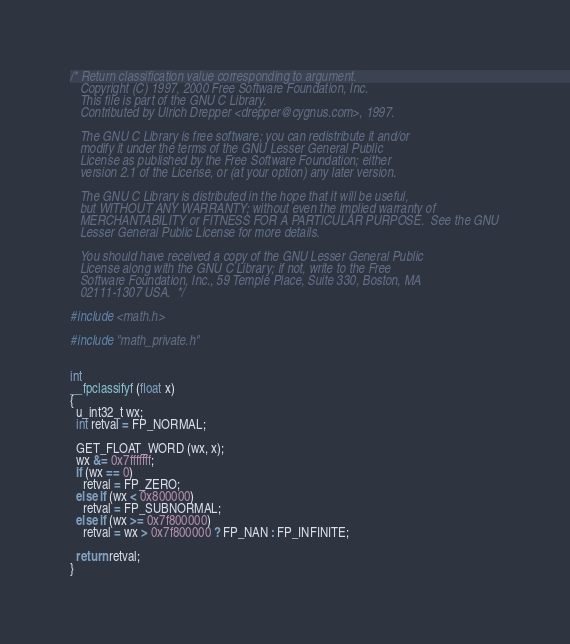Convert code to text. <code><loc_0><loc_0><loc_500><loc_500><_C_>/* Return classification value corresponding to argument.
   Copyright (C) 1997, 2000 Free Software Foundation, Inc.
   This file is part of the GNU C Library.
   Contributed by Ulrich Drepper <drepper@cygnus.com>, 1997.

   The GNU C Library is free software; you can redistribute it and/or
   modify it under the terms of the GNU Lesser General Public
   License as published by the Free Software Foundation; either
   version 2.1 of the License, or (at your option) any later version.

   The GNU C Library is distributed in the hope that it will be useful,
   but WITHOUT ANY WARRANTY; without even the implied warranty of
   MERCHANTABILITY or FITNESS FOR A PARTICULAR PURPOSE.  See the GNU
   Lesser General Public License for more details.

   You should have received a copy of the GNU Lesser General Public
   License along with the GNU C Library; if not, write to the Free
   Software Foundation, Inc., 59 Temple Place, Suite 330, Boston, MA
   02111-1307 USA.  */

#include <math.h>

#include "math_private.h"


int
__fpclassifyf (float x)
{
  u_int32_t wx;
  int retval = FP_NORMAL;

  GET_FLOAT_WORD (wx, x);
  wx &= 0x7fffffff;
  if (wx == 0)
    retval = FP_ZERO;
  else if (wx < 0x800000)
    retval = FP_SUBNORMAL;
  else if (wx >= 0x7f800000)
    retval = wx > 0x7f800000 ? FP_NAN : FP_INFINITE;

  return retval;
}
</code> 